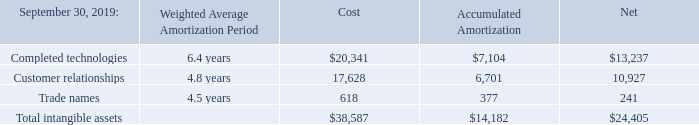Intangible assets
Intangible assets include the value assigned to completed technologies, customer relationships, and trade names. The estimated useful lives for all of these intangible assets, range from two to seven years. Intangible assets as of September 30, 2019 and 2018 are summarized as follows(amounts shown in thousands, except for years):
Amortization expense related to acquired intangible assets was $7.0 million, $4.0 million, and $0.6 million for fiscal years ended September 30, 2019, 2018, and 2017, respectively and is recorded in acquisition-related costs and expenses in the consolidated statements of operations.
What does intangible assets include? The value assigned to completed technologies, customer relationships, and trade names. What is the range of the estimated useful lives of the intangible assets? Two to seven years. What are the costs of completed technologies and customer relationships in 2019, respectively?
Answer scale should be: thousand. $20,341, 17,628. Which intangible assets have the highest proportion of accumulated amortization over cost in 2019? (377/618)>(6,701/17,628)>(7,104/20,341) = 0.61>0.38>0.35
Answer: trade names. What is the percentage constitution of the cost of customer relationships among the total cost of the total intangible assets in 2019?
Answer scale should be: percent. 17,628/38,587
Answer: 45.68. What is the average net value of the three categories of intangible assets in 2019?
Answer scale should be: thousand. (13,237+10,927+241)/3 
Answer: 8135. 